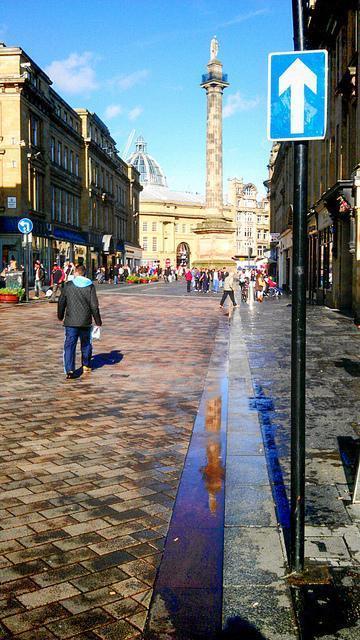How many people are there?
Give a very brief answer. 2. 